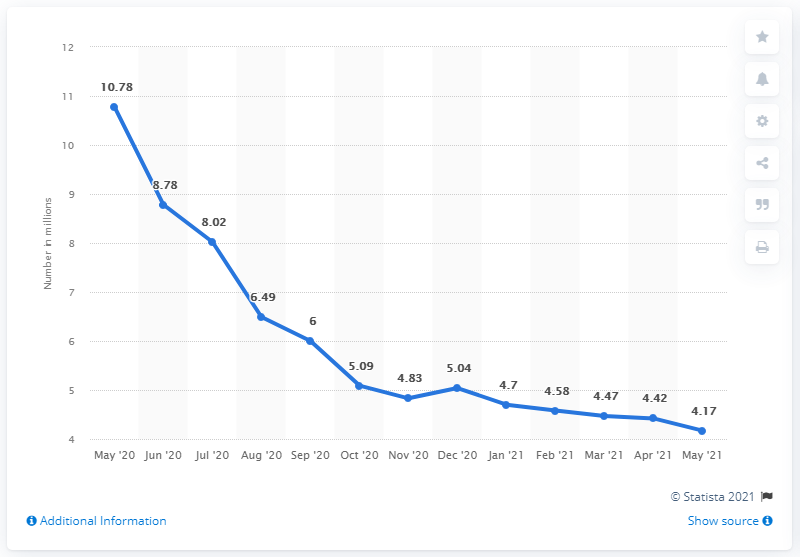Specify some key components in this picture. In May 2021, there were 4.17 million women who were unemployed in the United States. 